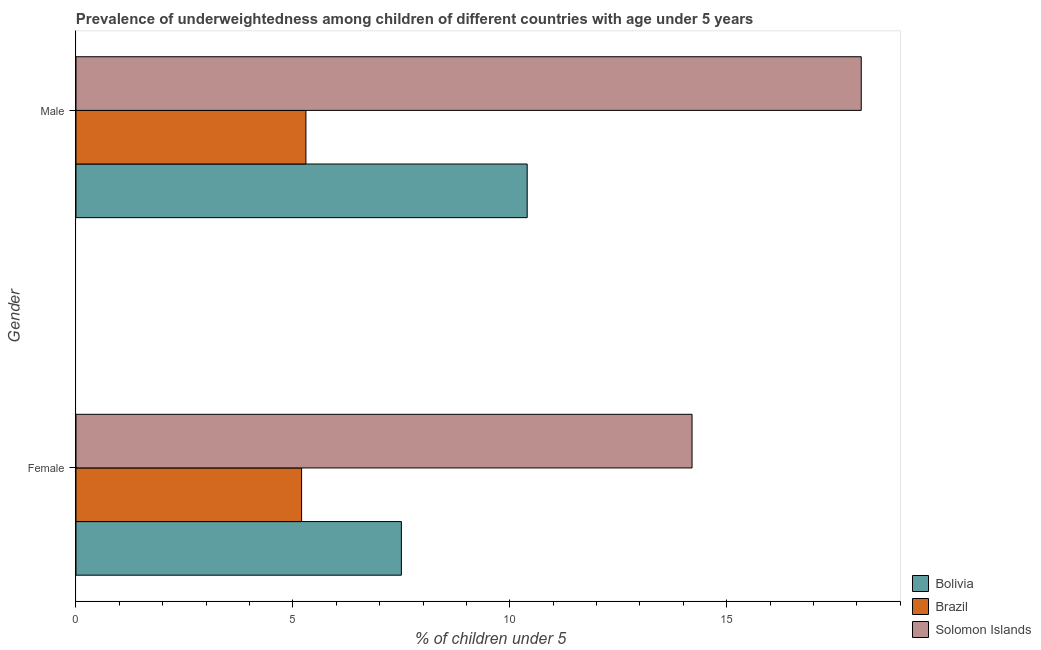Are the number of bars per tick equal to the number of legend labels?
Keep it short and to the point. Yes. What is the label of the 2nd group of bars from the top?
Provide a succinct answer. Female. What is the percentage of underweighted female children in Brazil?
Your answer should be very brief. 5.2. Across all countries, what is the maximum percentage of underweighted female children?
Give a very brief answer. 14.2. Across all countries, what is the minimum percentage of underweighted female children?
Your answer should be very brief. 5.2. In which country was the percentage of underweighted female children maximum?
Provide a succinct answer. Solomon Islands. What is the total percentage of underweighted female children in the graph?
Offer a very short reply. 26.9. What is the difference between the percentage of underweighted male children in Bolivia and that in Solomon Islands?
Provide a short and direct response. -7.7. What is the difference between the percentage of underweighted male children in Bolivia and the percentage of underweighted female children in Brazil?
Offer a terse response. 5.2. What is the average percentage of underweighted female children per country?
Provide a succinct answer. 8.97. What is the difference between the percentage of underweighted female children and percentage of underweighted male children in Brazil?
Keep it short and to the point. -0.1. What is the ratio of the percentage of underweighted male children in Bolivia to that in Solomon Islands?
Ensure brevity in your answer.  0.57. Is the percentage of underweighted female children in Solomon Islands less than that in Bolivia?
Offer a very short reply. No. In how many countries, is the percentage of underweighted male children greater than the average percentage of underweighted male children taken over all countries?
Make the answer very short. 1. What does the 1st bar from the top in Female represents?
Offer a very short reply. Solomon Islands. Are all the bars in the graph horizontal?
Give a very brief answer. Yes. What is the difference between two consecutive major ticks on the X-axis?
Provide a short and direct response. 5. Does the graph contain grids?
Your response must be concise. No. Where does the legend appear in the graph?
Ensure brevity in your answer.  Bottom right. How many legend labels are there?
Provide a short and direct response. 3. What is the title of the graph?
Provide a short and direct response. Prevalence of underweightedness among children of different countries with age under 5 years. Does "Uganda" appear as one of the legend labels in the graph?
Ensure brevity in your answer.  No. What is the label or title of the X-axis?
Make the answer very short.  % of children under 5. What is the  % of children under 5 in Brazil in Female?
Keep it short and to the point. 5.2. What is the  % of children under 5 in Solomon Islands in Female?
Ensure brevity in your answer.  14.2. What is the  % of children under 5 of Bolivia in Male?
Provide a short and direct response. 10.4. What is the  % of children under 5 in Brazil in Male?
Give a very brief answer. 5.3. What is the  % of children under 5 of Solomon Islands in Male?
Your answer should be very brief. 18.1. Across all Gender, what is the maximum  % of children under 5 of Bolivia?
Give a very brief answer. 10.4. Across all Gender, what is the maximum  % of children under 5 in Brazil?
Keep it short and to the point. 5.3. Across all Gender, what is the maximum  % of children under 5 of Solomon Islands?
Provide a succinct answer. 18.1. Across all Gender, what is the minimum  % of children under 5 of Bolivia?
Your response must be concise. 7.5. Across all Gender, what is the minimum  % of children under 5 in Brazil?
Provide a short and direct response. 5.2. Across all Gender, what is the minimum  % of children under 5 in Solomon Islands?
Provide a succinct answer. 14.2. What is the total  % of children under 5 of Bolivia in the graph?
Your answer should be compact. 17.9. What is the total  % of children under 5 in Brazil in the graph?
Your response must be concise. 10.5. What is the total  % of children under 5 in Solomon Islands in the graph?
Keep it short and to the point. 32.3. What is the difference between the  % of children under 5 of Brazil in Female and that in Male?
Keep it short and to the point. -0.1. What is the difference between the  % of children under 5 of Solomon Islands in Female and that in Male?
Provide a succinct answer. -3.9. What is the difference between the  % of children under 5 of Bolivia in Female and the  % of children under 5 of Brazil in Male?
Your answer should be compact. 2.2. What is the difference between the  % of children under 5 of Bolivia in Female and the  % of children under 5 of Solomon Islands in Male?
Your answer should be compact. -10.6. What is the difference between the  % of children under 5 of Brazil in Female and the  % of children under 5 of Solomon Islands in Male?
Keep it short and to the point. -12.9. What is the average  % of children under 5 of Bolivia per Gender?
Ensure brevity in your answer.  8.95. What is the average  % of children under 5 in Brazil per Gender?
Your answer should be very brief. 5.25. What is the average  % of children under 5 in Solomon Islands per Gender?
Offer a terse response. 16.15. What is the difference between the  % of children under 5 of Bolivia and  % of children under 5 of Brazil in Female?
Make the answer very short. 2.3. What is the difference between the  % of children under 5 in Bolivia and  % of children under 5 in Brazil in Male?
Offer a terse response. 5.1. What is the difference between the  % of children under 5 in Bolivia and  % of children under 5 in Solomon Islands in Male?
Offer a very short reply. -7.7. What is the ratio of the  % of children under 5 of Bolivia in Female to that in Male?
Your answer should be compact. 0.72. What is the ratio of the  % of children under 5 of Brazil in Female to that in Male?
Provide a short and direct response. 0.98. What is the ratio of the  % of children under 5 in Solomon Islands in Female to that in Male?
Provide a succinct answer. 0.78. What is the difference between the highest and the second highest  % of children under 5 of Bolivia?
Ensure brevity in your answer.  2.9. What is the difference between the highest and the second highest  % of children under 5 of Brazil?
Make the answer very short. 0.1. What is the difference between the highest and the lowest  % of children under 5 of Brazil?
Offer a terse response. 0.1. What is the difference between the highest and the lowest  % of children under 5 in Solomon Islands?
Offer a terse response. 3.9. 